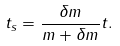Convert formula to latex. <formula><loc_0><loc_0><loc_500><loc_500>t _ { s } = \frac { \delta m } { m + \delta m } t .</formula> 